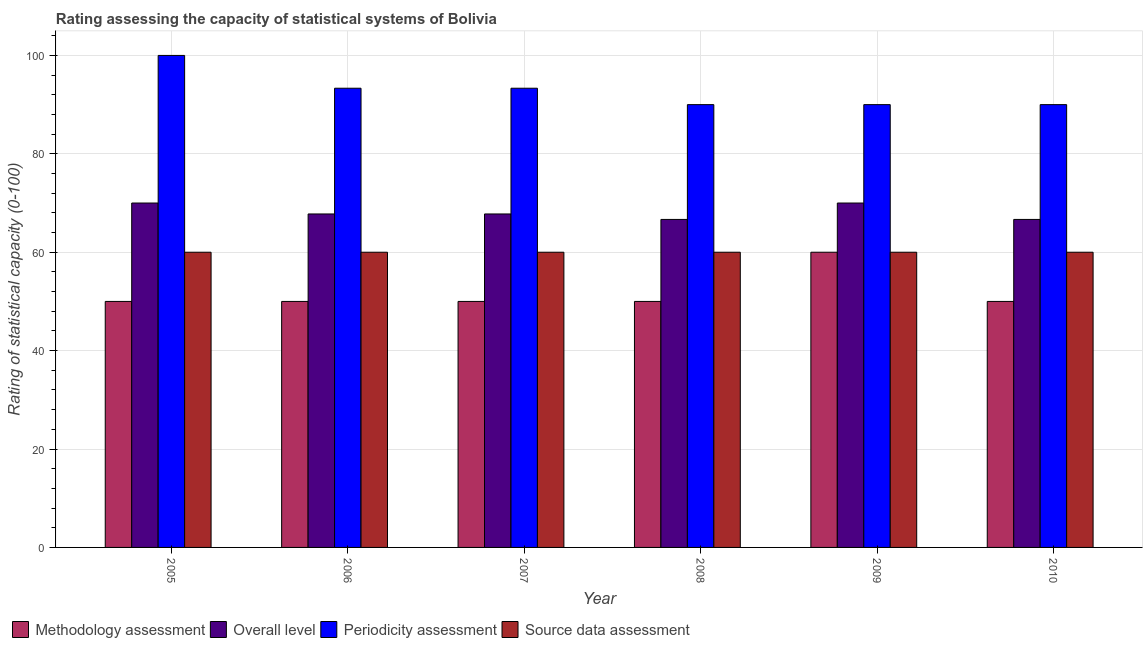How many groups of bars are there?
Your answer should be compact. 6. Are the number of bars per tick equal to the number of legend labels?
Give a very brief answer. Yes. How many bars are there on the 6th tick from the right?
Your response must be concise. 4. In how many cases, is the number of bars for a given year not equal to the number of legend labels?
Provide a succinct answer. 0. What is the source data assessment rating in 2010?
Make the answer very short. 60. Across all years, what is the minimum source data assessment rating?
Ensure brevity in your answer.  60. In which year was the overall level rating maximum?
Make the answer very short. 2005. What is the total source data assessment rating in the graph?
Ensure brevity in your answer.  360. What is the difference between the methodology assessment rating in 2006 and that in 2007?
Offer a terse response. 0. What is the average methodology assessment rating per year?
Your answer should be very brief. 51.67. Is the methodology assessment rating in 2005 less than that in 2010?
Your answer should be very brief. No. Is the sum of the periodicity assessment rating in 2006 and 2007 greater than the maximum overall level rating across all years?
Your response must be concise. Yes. Is it the case that in every year, the sum of the periodicity assessment rating and overall level rating is greater than the sum of source data assessment rating and methodology assessment rating?
Your answer should be compact. Yes. What does the 2nd bar from the left in 2007 represents?
Keep it short and to the point. Overall level. What does the 4th bar from the right in 2007 represents?
Make the answer very short. Methodology assessment. Are all the bars in the graph horizontal?
Keep it short and to the point. No. How many years are there in the graph?
Your answer should be very brief. 6. What is the difference between two consecutive major ticks on the Y-axis?
Offer a very short reply. 20. Does the graph contain any zero values?
Give a very brief answer. No. What is the title of the graph?
Make the answer very short. Rating assessing the capacity of statistical systems of Bolivia. What is the label or title of the Y-axis?
Your response must be concise. Rating of statistical capacity (0-100). What is the Rating of statistical capacity (0-100) of Methodology assessment in 2005?
Provide a succinct answer. 50. What is the Rating of statistical capacity (0-100) of Overall level in 2005?
Ensure brevity in your answer.  70. What is the Rating of statistical capacity (0-100) in Periodicity assessment in 2005?
Your response must be concise. 100. What is the Rating of statistical capacity (0-100) of Source data assessment in 2005?
Offer a very short reply. 60. What is the Rating of statistical capacity (0-100) in Methodology assessment in 2006?
Your answer should be compact. 50. What is the Rating of statistical capacity (0-100) of Overall level in 2006?
Your response must be concise. 67.78. What is the Rating of statistical capacity (0-100) of Periodicity assessment in 2006?
Your answer should be very brief. 93.33. What is the Rating of statistical capacity (0-100) in Source data assessment in 2006?
Offer a terse response. 60. What is the Rating of statistical capacity (0-100) in Methodology assessment in 2007?
Ensure brevity in your answer.  50. What is the Rating of statistical capacity (0-100) of Overall level in 2007?
Ensure brevity in your answer.  67.78. What is the Rating of statistical capacity (0-100) in Periodicity assessment in 2007?
Your answer should be compact. 93.33. What is the Rating of statistical capacity (0-100) in Source data assessment in 2007?
Your response must be concise. 60. What is the Rating of statistical capacity (0-100) of Overall level in 2008?
Provide a succinct answer. 66.67. What is the Rating of statistical capacity (0-100) of Periodicity assessment in 2008?
Keep it short and to the point. 90. What is the Rating of statistical capacity (0-100) in Source data assessment in 2008?
Your answer should be very brief. 60. What is the Rating of statistical capacity (0-100) of Overall level in 2009?
Keep it short and to the point. 70. What is the Rating of statistical capacity (0-100) of Source data assessment in 2009?
Give a very brief answer. 60. What is the Rating of statistical capacity (0-100) of Methodology assessment in 2010?
Provide a succinct answer. 50. What is the Rating of statistical capacity (0-100) of Overall level in 2010?
Your response must be concise. 66.67. What is the Rating of statistical capacity (0-100) of Periodicity assessment in 2010?
Ensure brevity in your answer.  90. What is the Rating of statistical capacity (0-100) of Source data assessment in 2010?
Provide a short and direct response. 60. Across all years, what is the maximum Rating of statistical capacity (0-100) of Overall level?
Provide a short and direct response. 70. Across all years, what is the maximum Rating of statistical capacity (0-100) in Periodicity assessment?
Keep it short and to the point. 100. Across all years, what is the maximum Rating of statistical capacity (0-100) of Source data assessment?
Make the answer very short. 60. Across all years, what is the minimum Rating of statistical capacity (0-100) in Overall level?
Your answer should be compact. 66.67. Across all years, what is the minimum Rating of statistical capacity (0-100) of Periodicity assessment?
Ensure brevity in your answer.  90. Across all years, what is the minimum Rating of statistical capacity (0-100) in Source data assessment?
Ensure brevity in your answer.  60. What is the total Rating of statistical capacity (0-100) in Methodology assessment in the graph?
Your response must be concise. 310. What is the total Rating of statistical capacity (0-100) in Overall level in the graph?
Your answer should be compact. 408.89. What is the total Rating of statistical capacity (0-100) of Periodicity assessment in the graph?
Your response must be concise. 556.67. What is the total Rating of statistical capacity (0-100) in Source data assessment in the graph?
Ensure brevity in your answer.  360. What is the difference between the Rating of statistical capacity (0-100) of Methodology assessment in 2005 and that in 2006?
Make the answer very short. 0. What is the difference between the Rating of statistical capacity (0-100) in Overall level in 2005 and that in 2006?
Make the answer very short. 2.22. What is the difference between the Rating of statistical capacity (0-100) in Source data assessment in 2005 and that in 2006?
Ensure brevity in your answer.  0. What is the difference between the Rating of statistical capacity (0-100) of Methodology assessment in 2005 and that in 2007?
Provide a short and direct response. 0. What is the difference between the Rating of statistical capacity (0-100) of Overall level in 2005 and that in 2007?
Offer a very short reply. 2.22. What is the difference between the Rating of statistical capacity (0-100) in Source data assessment in 2005 and that in 2007?
Provide a succinct answer. 0. What is the difference between the Rating of statistical capacity (0-100) of Methodology assessment in 2005 and that in 2008?
Ensure brevity in your answer.  0. What is the difference between the Rating of statistical capacity (0-100) of Overall level in 2005 and that in 2008?
Keep it short and to the point. 3.33. What is the difference between the Rating of statistical capacity (0-100) in Source data assessment in 2005 and that in 2008?
Keep it short and to the point. 0. What is the difference between the Rating of statistical capacity (0-100) of Overall level in 2005 and that in 2009?
Ensure brevity in your answer.  0. What is the difference between the Rating of statistical capacity (0-100) in Periodicity assessment in 2005 and that in 2009?
Provide a succinct answer. 10. What is the difference between the Rating of statistical capacity (0-100) in Periodicity assessment in 2005 and that in 2010?
Keep it short and to the point. 10. What is the difference between the Rating of statistical capacity (0-100) of Overall level in 2006 and that in 2007?
Offer a terse response. 0. What is the difference between the Rating of statistical capacity (0-100) of Methodology assessment in 2006 and that in 2008?
Provide a succinct answer. 0. What is the difference between the Rating of statistical capacity (0-100) of Periodicity assessment in 2006 and that in 2008?
Your answer should be compact. 3.33. What is the difference between the Rating of statistical capacity (0-100) of Source data assessment in 2006 and that in 2008?
Offer a terse response. 0. What is the difference between the Rating of statistical capacity (0-100) in Methodology assessment in 2006 and that in 2009?
Provide a succinct answer. -10. What is the difference between the Rating of statistical capacity (0-100) in Overall level in 2006 and that in 2009?
Your answer should be compact. -2.22. What is the difference between the Rating of statistical capacity (0-100) of Periodicity assessment in 2006 and that in 2009?
Keep it short and to the point. 3.33. What is the difference between the Rating of statistical capacity (0-100) in Source data assessment in 2006 and that in 2009?
Give a very brief answer. 0. What is the difference between the Rating of statistical capacity (0-100) of Periodicity assessment in 2006 and that in 2010?
Keep it short and to the point. 3.33. What is the difference between the Rating of statistical capacity (0-100) in Source data assessment in 2006 and that in 2010?
Your answer should be very brief. 0. What is the difference between the Rating of statistical capacity (0-100) of Methodology assessment in 2007 and that in 2008?
Your response must be concise. 0. What is the difference between the Rating of statistical capacity (0-100) in Periodicity assessment in 2007 and that in 2008?
Keep it short and to the point. 3.33. What is the difference between the Rating of statistical capacity (0-100) in Source data assessment in 2007 and that in 2008?
Provide a succinct answer. 0. What is the difference between the Rating of statistical capacity (0-100) in Methodology assessment in 2007 and that in 2009?
Your response must be concise. -10. What is the difference between the Rating of statistical capacity (0-100) of Overall level in 2007 and that in 2009?
Make the answer very short. -2.22. What is the difference between the Rating of statistical capacity (0-100) in Source data assessment in 2007 and that in 2009?
Keep it short and to the point. 0. What is the difference between the Rating of statistical capacity (0-100) of Overall level in 2007 and that in 2010?
Ensure brevity in your answer.  1.11. What is the difference between the Rating of statistical capacity (0-100) in Periodicity assessment in 2007 and that in 2010?
Your response must be concise. 3.33. What is the difference between the Rating of statistical capacity (0-100) of Methodology assessment in 2008 and that in 2009?
Give a very brief answer. -10. What is the difference between the Rating of statistical capacity (0-100) in Source data assessment in 2008 and that in 2009?
Give a very brief answer. 0. What is the difference between the Rating of statistical capacity (0-100) of Overall level in 2008 and that in 2010?
Offer a very short reply. 0. What is the difference between the Rating of statistical capacity (0-100) in Source data assessment in 2008 and that in 2010?
Keep it short and to the point. 0. What is the difference between the Rating of statistical capacity (0-100) in Methodology assessment in 2009 and that in 2010?
Your answer should be compact. 10. What is the difference between the Rating of statistical capacity (0-100) in Overall level in 2009 and that in 2010?
Your answer should be compact. 3.33. What is the difference between the Rating of statistical capacity (0-100) of Methodology assessment in 2005 and the Rating of statistical capacity (0-100) of Overall level in 2006?
Keep it short and to the point. -17.78. What is the difference between the Rating of statistical capacity (0-100) of Methodology assessment in 2005 and the Rating of statistical capacity (0-100) of Periodicity assessment in 2006?
Provide a short and direct response. -43.33. What is the difference between the Rating of statistical capacity (0-100) in Overall level in 2005 and the Rating of statistical capacity (0-100) in Periodicity assessment in 2006?
Offer a terse response. -23.33. What is the difference between the Rating of statistical capacity (0-100) of Periodicity assessment in 2005 and the Rating of statistical capacity (0-100) of Source data assessment in 2006?
Make the answer very short. 40. What is the difference between the Rating of statistical capacity (0-100) of Methodology assessment in 2005 and the Rating of statistical capacity (0-100) of Overall level in 2007?
Ensure brevity in your answer.  -17.78. What is the difference between the Rating of statistical capacity (0-100) in Methodology assessment in 2005 and the Rating of statistical capacity (0-100) in Periodicity assessment in 2007?
Provide a succinct answer. -43.33. What is the difference between the Rating of statistical capacity (0-100) of Overall level in 2005 and the Rating of statistical capacity (0-100) of Periodicity assessment in 2007?
Make the answer very short. -23.33. What is the difference between the Rating of statistical capacity (0-100) of Overall level in 2005 and the Rating of statistical capacity (0-100) of Source data assessment in 2007?
Your answer should be very brief. 10. What is the difference between the Rating of statistical capacity (0-100) of Periodicity assessment in 2005 and the Rating of statistical capacity (0-100) of Source data assessment in 2007?
Your response must be concise. 40. What is the difference between the Rating of statistical capacity (0-100) in Methodology assessment in 2005 and the Rating of statistical capacity (0-100) in Overall level in 2008?
Offer a terse response. -16.67. What is the difference between the Rating of statistical capacity (0-100) of Methodology assessment in 2005 and the Rating of statistical capacity (0-100) of Source data assessment in 2008?
Your answer should be compact. -10. What is the difference between the Rating of statistical capacity (0-100) of Overall level in 2005 and the Rating of statistical capacity (0-100) of Periodicity assessment in 2008?
Ensure brevity in your answer.  -20. What is the difference between the Rating of statistical capacity (0-100) of Periodicity assessment in 2005 and the Rating of statistical capacity (0-100) of Source data assessment in 2008?
Keep it short and to the point. 40. What is the difference between the Rating of statistical capacity (0-100) in Methodology assessment in 2005 and the Rating of statistical capacity (0-100) in Overall level in 2009?
Keep it short and to the point. -20. What is the difference between the Rating of statistical capacity (0-100) in Overall level in 2005 and the Rating of statistical capacity (0-100) in Source data assessment in 2009?
Your response must be concise. 10. What is the difference between the Rating of statistical capacity (0-100) of Periodicity assessment in 2005 and the Rating of statistical capacity (0-100) of Source data assessment in 2009?
Keep it short and to the point. 40. What is the difference between the Rating of statistical capacity (0-100) in Methodology assessment in 2005 and the Rating of statistical capacity (0-100) in Overall level in 2010?
Ensure brevity in your answer.  -16.67. What is the difference between the Rating of statistical capacity (0-100) in Methodology assessment in 2005 and the Rating of statistical capacity (0-100) in Source data assessment in 2010?
Ensure brevity in your answer.  -10. What is the difference between the Rating of statistical capacity (0-100) of Periodicity assessment in 2005 and the Rating of statistical capacity (0-100) of Source data assessment in 2010?
Make the answer very short. 40. What is the difference between the Rating of statistical capacity (0-100) of Methodology assessment in 2006 and the Rating of statistical capacity (0-100) of Overall level in 2007?
Keep it short and to the point. -17.78. What is the difference between the Rating of statistical capacity (0-100) of Methodology assessment in 2006 and the Rating of statistical capacity (0-100) of Periodicity assessment in 2007?
Ensure brevity in your answer.  -43.33. What is the difference between the Rating of statistical capacity (0-100) in Overall level in 2006 and the Rating of statistical capacity (0-100) in Periodicity assessment in 2007?
Keep it short and to the point. -25.56. What is the difference between the Rating of statistical capacity (0-100) of Overall level in 2006 and the Rating of statistical capacity (0-100) of Source data assessment in 2007?
Your answer should be very brief. 7.78. What is the difference between the Rating of statistical capacity (0-100) of Periodicity assessment in 2006 and the Rating of statistical capacity (0-100) of Source data assessment in 2007?
Provide a succinct answer. 33.33. What is the difference between the Rating of statistical capacity (0-100) of Methodology assessment in 2006 and the Rating of statistical capacity (0-100) of Overall level in 2008?
Ensure brevity in your answer.  -16.67. What is the difference between the Rating of statistical capacity (0-100) of Methodology assessment in 2006 and the Rating of statistical capacity (0-100) of Periodicity assessment in 2008?
Your answer should be compact. -40. What is the difference between the Rating of statistical capacity (0-100) of Methodology assessment in 2006 and the Rating of statistical capacity (0-100) of Source data assessment in 2008?
Offer a terse response. -10. What is the difference between the Rating of statistical capacity (0-100) of Overall level in 2006 and the Rating of statistical capacity (0-100) of Periodicity assessment in 2008?
Provide a succinct answer. -22.22. What is the difference between the Rating of statistical capacity (0-100) in Overall level in 2006 and the Rating of statistical capacity (0-100) in Source data assessment in 2008?
Ensure brevity in your answer.  7.78. What is the difference between the Rating of statistical capacity (0-100) in Periodicity assessment in 2006 and the Rating of statistical capacity (0-100) in Source data assessment in 2008?
Your answer should be compact. 33.33. What is the difference between the Rating of statistical capacity (0-100) in Methodology assessment in 2006 and the Rating of statistical capacity (0-100) in Overall level in 2009?
Offer a very short reply. -20. What is the difference between the Rating of statistical capacity (0-100) of Methodology assessment in 2006 and the Rating of statistical capacity (0-100) of Source data assessment in 2009?
Offer a very short reply. -10. What is the difference between the Rating of statistical capacity (0-100) of Overall level in 2006 and the Rating of statistical capacity (0-100) of Periodicity assessment in 2009?
Offer a very short reply. -22.22. What is the difference between the Rating of statistical capacity (0-100) of Overall level in 2006 and the Rating of statistical capacity (0-100) of Source data assessment in 2009?
Your answer should be compact. 7.78. What is the difference between the Rating of statistical capacity (0-100) of Periodicity assessment in 2006 and the Rating of statistical capacity (0-100) of Source data assessment in 2009?
Ensure brevity in your answer.  33.33. What is the difference between the Rating of statistical capacity (0-100) of Methodology assessment in 2006 and the Rating of statistical capacity (0-100) of Overall level in 2010?
Ensure brevity in your answer.  -16.67. What is the difference between the Rating of statistical capacity (0-100) in Methodology assessment in 2006 and the Rating of statistical capacity (0-100) in Periodicity assessment in 2010?
Make the answer very short. -40. What is the difference between the Rating of statistical capacity (0-100) of Methodology assessment in 2006 and the Rating of statistical capacity (0-100) of Source data assessment in 2010?
Your answer should be compact. -10. What is the difference between the Rating of statistical capacity (0-100) of Overall level in 2006 and the Rating of statistical capacity (0-100) of Periodicity assessment in 2010?
Your answer should be compact. -22.22. What is the difference between the Rating of statistical capacity (0-100) in Overall level in 2006 and the Rating of statistical capacity (0-100) in Source data assessment in 2010?
Give a very brief answer. 7.78. What is the difference between the Rating of statistical capacity (0-100) in Periodicity assessment in 2006 and the Rating of statistical capacity (0-100) in Source data assessment in 2010?
Keep it short and to the point. 33.33. What is the difference between the Rating of statistical capacity (0-100) of Methodology assessment in 2007 and the Rating of statistical capacity (0-100) of Overall level in 2008?
Your answer should be compact. -16.67. What is the difference between the Rating of statistical capacity (0-100) of Methodology assessment in 2007 and the Rating of statistical capacity (0-100) of Source data assessment in 2008?
Give a very brief answer. -10. What is the difference between the Rating of statistical capacity (0-100) in Overall level in 2007 and the Rating of statistical capacity (0-100) in Periodicity assessment in 2008?
Provide a short and direct response. -22.22. What is the difference between the Rating of statistical capacity (0-100) of Overall level in 2007 and the Rating of statistical capacity (0-100) of Source data assessment in 2008?
Your answer should be compact. 7.78. What is the difference between the Rating of statistical capacity (0-100) of Periodicity assessment in 2007 and the Rating of statistical capacity (0-100) of Source data assessment in 2008?
Make the answer very short. 33.33. What is the difference between the Rating of statistical capacity (0-100) of Overall level in 2007 and the Rating of statistical capacity (0-100) of Periodicity assessment in 2009?
Keep it short and to the point. -22.22. What is the difference between the Rating of statistical capacity (0-100) of Overall level in 2007 and the Rating of statistical capacity (0-100) of Source data assessment in 2009?
Ensure brevity in your answer.  7.78. What is the difference between the Rating of statistical capacity (0-100) in Periodicity assessment in 2007 and the Rating of statistical capacity (0-100) in Source data assessment in 2009?
Give a very brief answer. 33.33. What is the difference between the Rating of statistical capacity (0-100) in Methodology assessment in 2007 and the Rating of statistical capacity (0-100) in Overall level in 2010?
Keep it short and to the point. -16.67. What is the difference between the Rating of statistical capacity (0-100) of Methodology assessment in 2007 and the Rating of statistical capacity (0-100) of Periodicity assessment in 2010?
Your response must be concise. -40. What is the difference between the Rating of statistical capacity (0-100) in Methodology assessment in 2007 and the Rating of statistical capacity (0-100) in Source data assessment in 2010?
Keep it short and to the point. -10. What is the difference between the Rating of statistical capacity (0-100) of Overall level in 2007 and the Rating of statistical capacity (0-100) of Periodicity assessment in 2010?
Ensure brevity in your answer.  -22.22. What is the difference between the Rating of statistical capacity (0-100) of Overall level in 2007 and the Rating of statistical capacity (0-100) of Source data assessment in 2010?
Offer a terse response. 7.78. What is the difference between the Rating of statistical capacity (0-100) in Periodicity assessment in 2007 and the Rating of statistical capacity (0-100) in Source data assessment in 2010?
Keep it short and to the point. 33.33. What is the difference between the Rating of statistical capacity (0-100) of Methodology assessment in 2008 and the Rating of statistical capacity (0-100) of Overall level in 2009?
Give a very brief answer. -20. What is the difference between the Rating of statistical capacity (0-100) in Methodology assessment in 2008 and the Rating of statistical capacity (0-100) in Source data assessment in 2009?
Offer a very short reply. -10. What is the difference between the Rating of statistical capacity (0-100) in Overall level in 2008 and the Rating of statistical capacity (0-100) in Periodicity assessment in 2009?
Keep it short and to the point. -23.33. What is the difference between the Rating of statistical capacity (0-100) in Methodology assessment in 2008 and the Rating of statistical capacity (0-100) in Overall level in 2010?
Offer a very short reply. -16.67. What is the difference between the Rating of statistical capacity (0-100) in Methodology assessment in 2008 and the Rating of statistical capacity (0-100) in Periodicity assessment in 2010?
Offer a terse response. -40. What is the difference between the Rating of statistical capacity (0-100) in Overall level in 2008 and the Rating of statistical capacity (0-100) in Periodicity assessment in 2010?
Make the answer very short. -23.33. What is the difference between the Rating of statistical capacity (0-100) in Overall level in 2008 and the Rating of statistical capacity (0-100) in Source data assessment in 2010?
Give a very brief answer. 6.67. What is the difference between the Rating of statistical capacity (0-100) of Methodology assessment in 2009 and the Rating of statistical capacity (0-100) of Overall level in 2010?
Provide a succinct answer. -6.67. What is the difference between the Rating of statistical capacity (0-100) in Methodology assessment in 2009 and the Rating of statistical capacity (0-100) in Periodicity assessment in 2010?
Your answer should be very brief. -30. What is the difference between the Rating of statistical capacity (0-100) of Overall level in 2009 and the Rating of statistical capacity (0-100) of Source data assessment in 2010?
Your response must be concise. 10. What is the average Rating of statistical capacity (0-100) of Methodology assessment per year?
Provide a short and direct response. 51.67. What is the average Rating of statistical capacity (0-100) of Overall level per year?
Your answer should be compact. 68.15. What is the average Rating of statistical capacity (0-100) in Periodicity assessment per year?
Give a very brief answer. 92.78. In the year 2005, what is the difference between the Rating of statistical capacity (0-100) of Methodology assessment and Rating of statistical capacity (0-100) of Overall level?
Ensure brevity in your answer.  -20. In the year 2005, what is the difference between the Rating of statistical capacity (0-100) of Methodology assessment and Rating of statistical capacity (0-100) of Periodicity assessment?
Provide a short and direct response. -50. In the year 2005, what is the difference between the Rating of statistical capacity (0-100) in Overall level and Rating of statistical capacity (0-100) in Periodicity assessment?
Provide a short and direct response. -30. In the year 2006, what is the difference between the Rating of statistical capacity (0-100) of Methodology assessment and Rating of statistical capacity (0-100) of Overall level?
Ensure brevity in your answer.  -17.78. In the year 2006, what is the difference between the Rating of statistical capacity (0-100) of Methodology assessment and Rating of statistical capacity (0-100) of Periodicity assessment?
Provide a succinct answer. -43.33. In the year 2006, what is the difference between the Rating of statistical capacity (0-100) of Overall level and Rating of statistical capacity (0-100) of Periodicity assessment?
Your answer should be very brief. -25.56. In the year 2006, what is the difference between the Rating of statistical capacity (0-100) in Overall level and Rating of statistical capacity (0-100) in Source data assessment?
Your response must be concise. 7.78. In the year 2006, what is the difference between the Rating of statistical capacity (0-100) of Periodicity assessment and Rating of statistical capacity (0-100) of Source data assessment?
Make the answer very short. 33.33. In the year 2007, what is the difference between the Rating of statistical capacity (0-100) of Methodology assessment and Rating of statistical capacity (0-100) of Overall level?
Offer a very short reply. -17.78. In the year 2007, what is the difference between the Rating of statistical capacity (0-100) of Methodology assessment and Rating of statistical capacity (0-100) of Periodicity assessment?
Your answer should be very brief. -43.33. In the year 2007, what is the difference between the Rating of statistical capacity (0-100) in Overall level and Rating of statistical capacity (0-100) in Periodicity assessment?
Your answer should be very brief. -25.56. In the year 2007, what is the difference between the Rating of statistical capacity (0-100) of Overall level and Rating of statistical capacity (0-100) of Source data assessment?
Give a very brief answer. 7.78. In the year 2007, what is the difference between the Rating of statistical capacity (0-100) of Periodicity assessment and Rating of statistical capacity (0-100) of Source data assessment?
Ensure brevity in your answer.  33.33. In the year 2008, what is the difference between the Rating of statistical capacity (0-100) of Methodology assessment and Rating of statistical capacity (0-100) of Overall level?
Provide a short and direct response. -16.67. In the year 2008, what is the difference between the Rating of statistical capacity (0-100) of Methodology assessment and Rating of statistical capacity (0-100) of Periodicity assessment?
Offer a terse response. -40. In the year 2008, what is the difference between the Rating of statistical capacity (0-100) in Overall level and Rating of statistical capacity (0-100) in Periodicity assessment?
Your answer should be very brief. -23.33. In the year 2009, what is the difference between the Rating of statistical capacity (0-100) of Methodology assessment and Rating of statistical capacity (0-100) of Periodicity assessment?
Ensure brevity in your answer.  -30. In the year 2009, what is the difference between the Rating of statistical capacity (0-100) in Overall level and Rating of statistical capacity (0-100) in Periodicity assessment?
Make the answer very short. -20. In the year 2010, what is the difference between the Rating of statistical capacity (0-100) in Methodology assessment and Rating of statistical capacity (0-100) in Overall level?
Make the answer very short. -16.67. In the year 2010, what is the difference between the Rating of statistical capacity (0-100) in Overall level and Rating of statistical capacity (0-100) in Periodicity assessment?
Your response must be concise. -23.33. In the year 2010, what is the difference between the Rating of statistical capacity (0-100) of Periodicity assessment and Rating of statistical capacity (0-100) of Source data assessment?
Provide a short and direct response. 30. What is the ratio of the Rating of statistical capacity (0-100) of Methodology assessment in 2005 to that in 2006?
Provide a short and direct response. 1. What is the ratio of the Rating of statistical capacity (0-100) in Overall level in 2005 to that in 2006?
Your answer should be compact. 1.03. What is the ratio of the Rating of statistical capacity (0-100) of Periodicity assessment in 2005 to that in 2006?
Your answer should be compact. 1.07. What is the ratio of the Rating of statistical capacity (0-100) of Methodology assessment in 2005 to that in 2007?
Provide a succinct answer. 1. What is the ratio of the Rating of statistical capacity (0-100) in Overall level in 2005 to that in 2007?
Your answer should be compact. 1.03. What is the ratio of the Rating of statistical capacity (0-100) of Periodicity assessment in 2005 to that in 2007?
Ensure brevity in your answer.  1.07. What is the ratio of the Rating of statistical capacity (0-100) of Source data assessment in 2005 to that in 2007?
Ensure brevity in your answer.  1. What is the ratio of the Rating of statistical capacity (0-100) of Methodology assessment in 2005 to that in 2008?
Give a very brief answer. 1. What is the ratio of the Rating of statistical capacity (0-100) of Source data assessment in 2005 to that in 2008?
Provide a succinct answer. 1. What is the ratio of the Rating of statistical capacity (0-100) in Methodology assessment in 2005 to that in 2009?
Ensure brevity in your answer.  0.83. What is the ratio of the Rating of statistical capacity (0-100) in Methodology assessment in 2005 to that in 2010?
Make the answer very short. 1. What is the ratio of the Rating of statistical capacity (0-100) in Methodology assessment in 2006 to that in 2007?
Ensure brevity in your answer.  1. What is the ratio of the Rating of statistical capacity (0-100) in Overall level in 2006 to that in 2007?
Keep it short and to the point. 1. What is the ratio of the Rating of statistical capacity (0-100) in Periodicity assessment in 2006 to that in 2007?
Offer a terse response. 1. What is the ratio of the Rating of statistical capacity (0-100) in Source data assessment in 2006 to that in 2007?
Keep it short and to the point. 1. What is the ratio of the Rating of statistical capacity (0-100) in Methodology assessment in 2006 to that in 2008?
Your answer should be very brief. 1. What is the ratio of the Rating of statistical capacity (0-100) of Overall level in 2006 to that in 2008?
Provide a succinct answer. 1.02. What is the ratio of the Rating of statistical capacity (0-100) of Periodicity assessment in 2006 to that in 2008?
Your answer should be very brief. 1.04. What is the ratio of the Rating of statistical capacity (0-100) of Methodology assessment in 2006 to that in 2009?
Make the answer very short. 0.83. What is the ratio of the Rating of statistical capacity (0-100) of Overall level in 2006 to that in 2009?
Give a very brief answer. 0.97. What is the ratio of the Rating of statistical capacity (0-100) in Methodology assessment in 2006 to that in 2010?
Keep it short and to the point. 1. What is the ratio of the Rating of statistical capacity (0-100) in Overall level in 2006 to that in 2010?
Ensure brevity in your answer.  1.02. What is the ratio of the Rating of statistical capacity (0-100) in Periodicity assessment in 2006 to that in 2010?
Keep it short and to the point. 1.04. What is the ratio of the Rating of statistical capacity (0-100) of Source data assessment in 2006 to that in 2010?
Your answer should be very brief. 1. What is the ratio of the Rating of statistical capacity (0-100) of Overall level in 2007 to that in 2008?
Offer a very short reply. 1.02. What is the ratio of the Rating of statistical capacity (0-100) in Periodicity assessment in 2007 to that in 2008?
Provide a short and direct response. 1.04. What is the ratio of the Rating of statistical capacity (0-100) in Source data assessment in 2007 to that in 2008?
Provide a succinct answer. 1. What is the ratio of the Rating of statistical capacity (0-100) in Methodology assessment in 2007 to that in 2009?
Your answer should be very brief. 0.83. What is the ratio of the Rating of statistical capacity (0-100) of Overall level in 2007 to that in 2009?
Keep it short and to the point. 0.97. What is the ratio of the Rating of statistical capacity (0-100) in Source data assessment in 2007 to that in 2009?
Your response must be concise. 1. What is the ratio of the Rating of statistical capacity (0-100) of Overall level in 2007 to that in 2010?
Make the answer very short. 1.02. What is the ratio of the Rating of statistical capacity (0-100) in Periodicity assessment in 2007 to that in 2010?
Your answer should be compact. 1.04. What is the ratio of the Rating of statistical capacity (0-100) of Overall level in 2008 to that in 2009?
Make the answer very short. 0.95. What is the ratio of the Rating of statistical capacity (0-100) of Periodicity assessment in 2008 to that in 2009?
Offer a very short reply. 1. What is the ratio of the Rating of statistical capacity (0-100) in Source data assessment in 2008 to that in 2009?
Your answer should be very brief. 1. What is the ratio of the Rating of statistical capacity (0-100) of Methodology assessment in 2008 to that in 2010?
Provide a succinct answer. 1. What is the ratio of the Rating of statistical capacity (0-100) of Overall level in 2008 to that in 2010?
Offer a very short reply. 1. What is the ratio of the Rating of statistical capacity (0-100) of Overall level in 2009 to that in 2010?
Offer a very short reply. 1.05. What is the ratio of the Rating of statistical capacity (0-100) of Periodicity assessment in 2009 to that in 2010?
Give a very brief answer. 1. What is the ratio of the Rating of statistical capacity (0-100) of Source data assessment in 2009 to that in 2010?
Provide a succinct answer. 1. What is the difference between the highest and the second highest Rating of statistical capacity (0-100) in Methodology assessment?
Provide a short and direct response. 10. What is the difference between the highest and the second highest Rating of statistical capacity (0-100) in Periodicity assessment?
Your answer should be very brief. 6.67. What is the difference between the highest and the lowest Rating of statistical capacity (0-100) of Overall level?
Give a very brief answer. 3.33. 